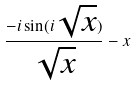<formula> <loc_0><loc_0><loc_500><loc_500>\frac { - i \sin ( i \sqrt { x } ) } { \sqrt { x } } - x</formula> 